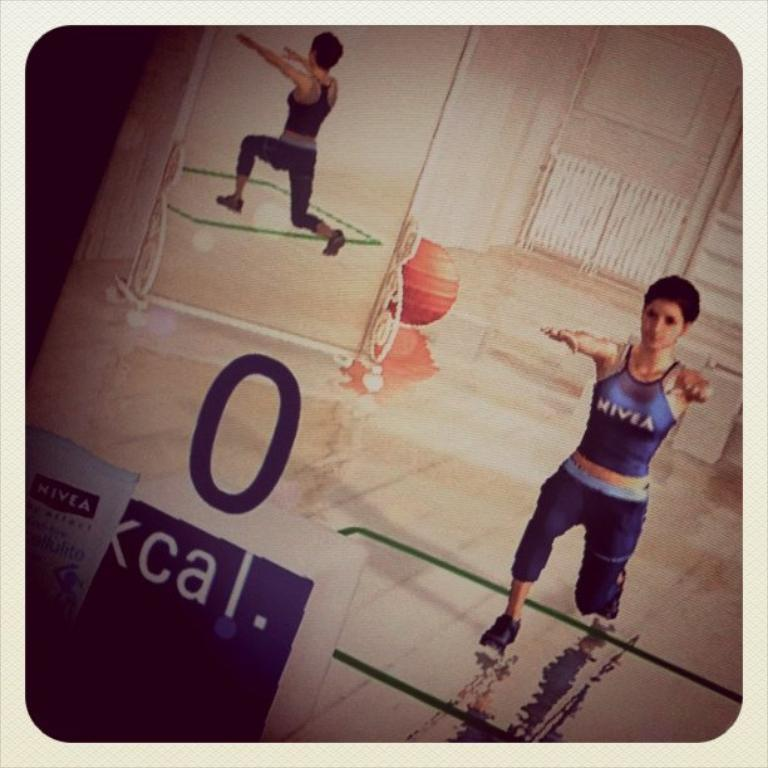Who is the main subject in the image? There is a girl in the image. What object can be seen near the girl? There is a ball in the image. What reflective surface is present in the image? There is a mirror in the image. What type of structure is visible in the background? There is a wall in the image. How much credit does the girl have on her phone in the image? There is no information about the girl's phone or credit in the image. Is the girl's sister present in the image? There is no mention of a sister or any other family members in the image. 